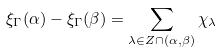Convert formula to latex. <formula><loc_0><loc_0><loc_500><loc_500>\xi _ { \Gamma } ( \alpha ) - \xi _ { \Gamma } ( \beta ) = \sum _ { \lambda \in Z \cap ( \alpha , \beta ) } \chi _ { \lambda }</formula> 